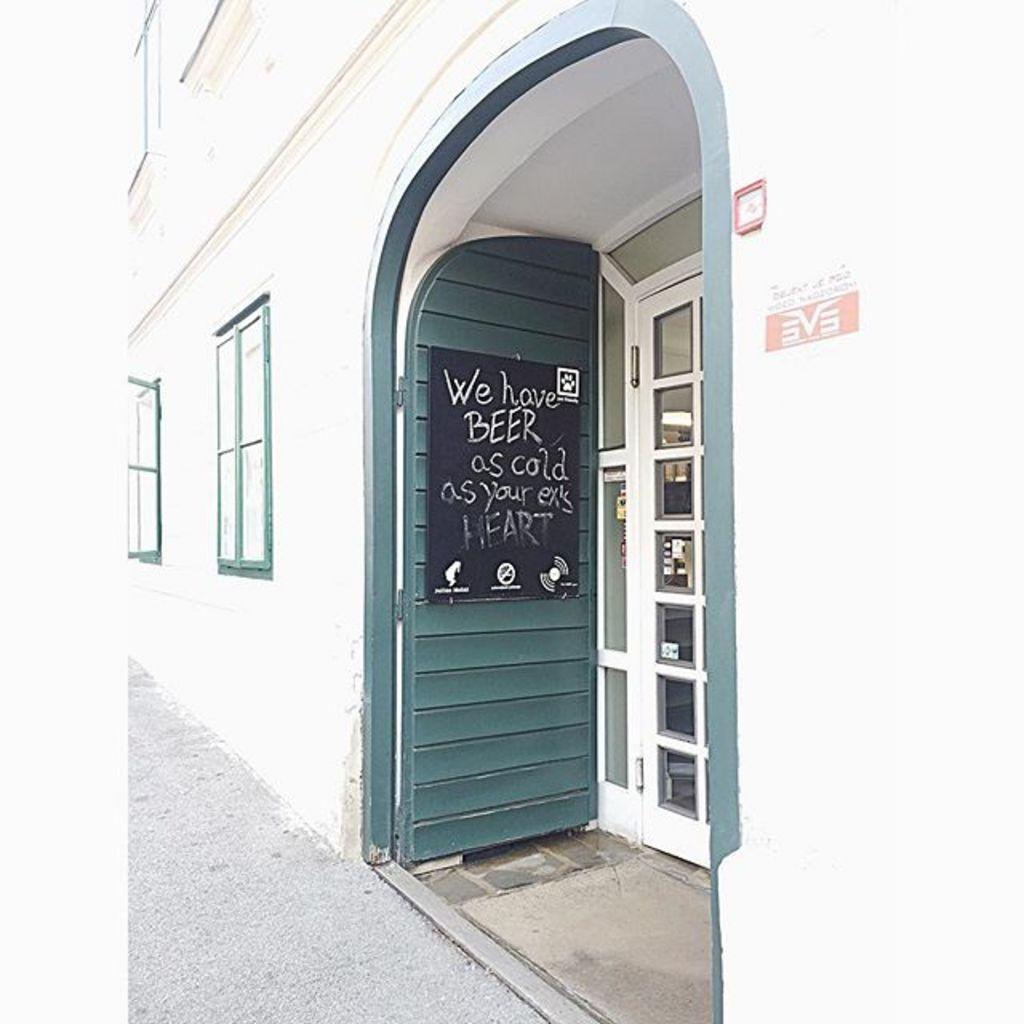Describe this image in one or two sentences. This picture is clicked outside. On the right we can see the text on the board which is attached to the door and we can see windows and a white color door of the building and we can see some other objects and the ground. 